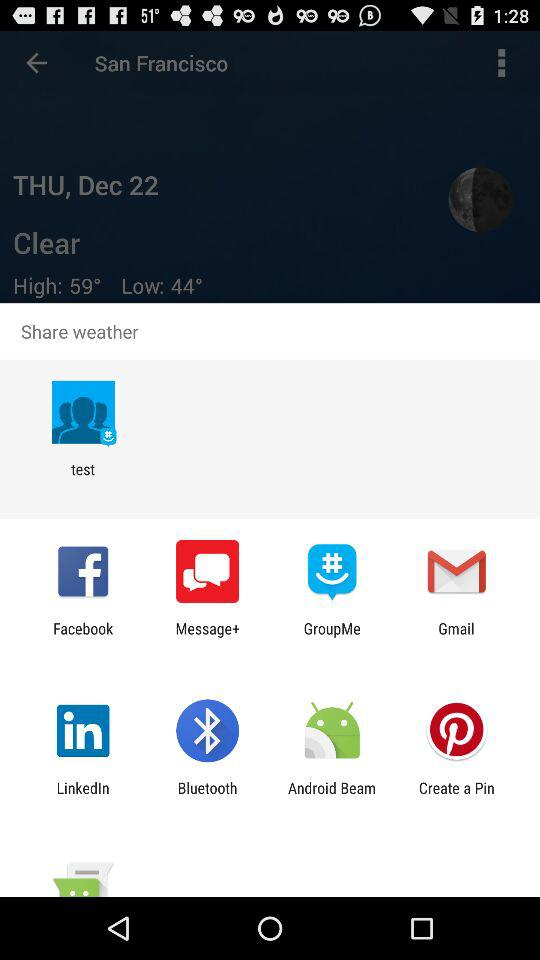What is the year?
When the provided information is insufficient, respond with <no answer>. <no answer> 